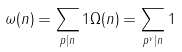Convert formula to latex. <formula><loc_0><loc_0><loc_500><loc_500>\omega ( n ) = \sum _ { p | n } 1 \Omega ( n ) = \sum _ { p ^ { v } | n } 1</formula> 